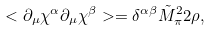<formula> <loc_0><loc_0><loc_500><loc_500>< \partial _ { \mu } { \chi } ^ { \alpha } \partial _ { \mu } { \chi } ^ { \beta } > = \delta ^ { \alpha \beta } { \tilde { M } } _ { \pi } ^ { 2 } 2 \rho ,</formula> 